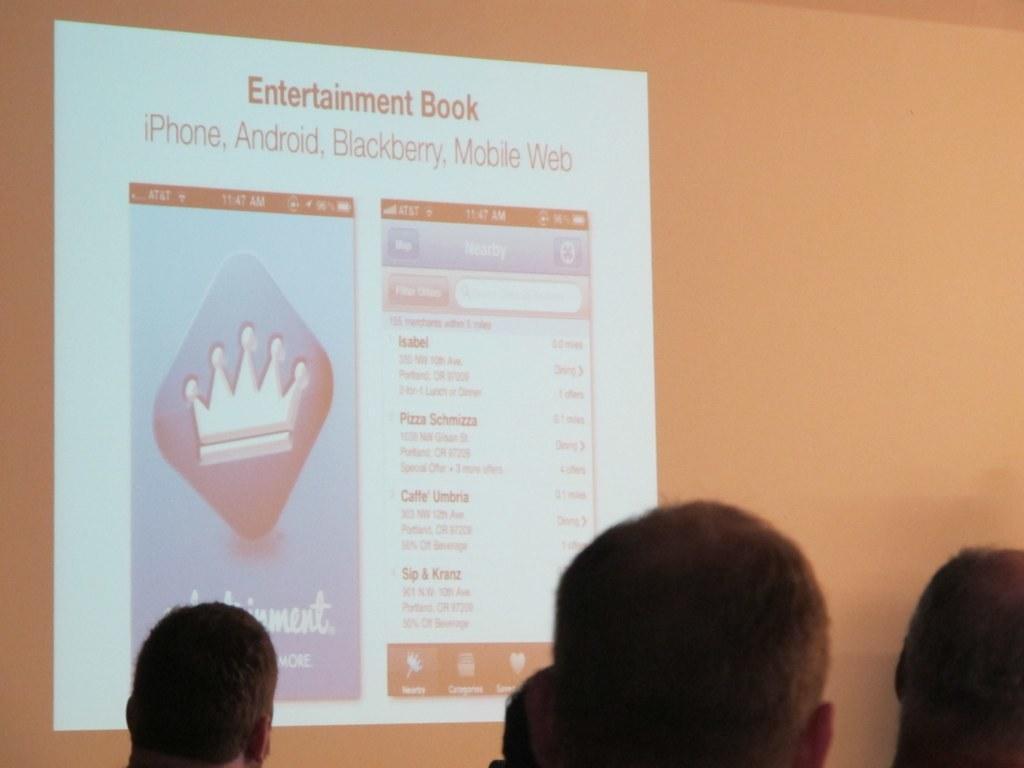Describe this image in one or two sentences. In this image I can see group of people, in front I can see a projector screen. 